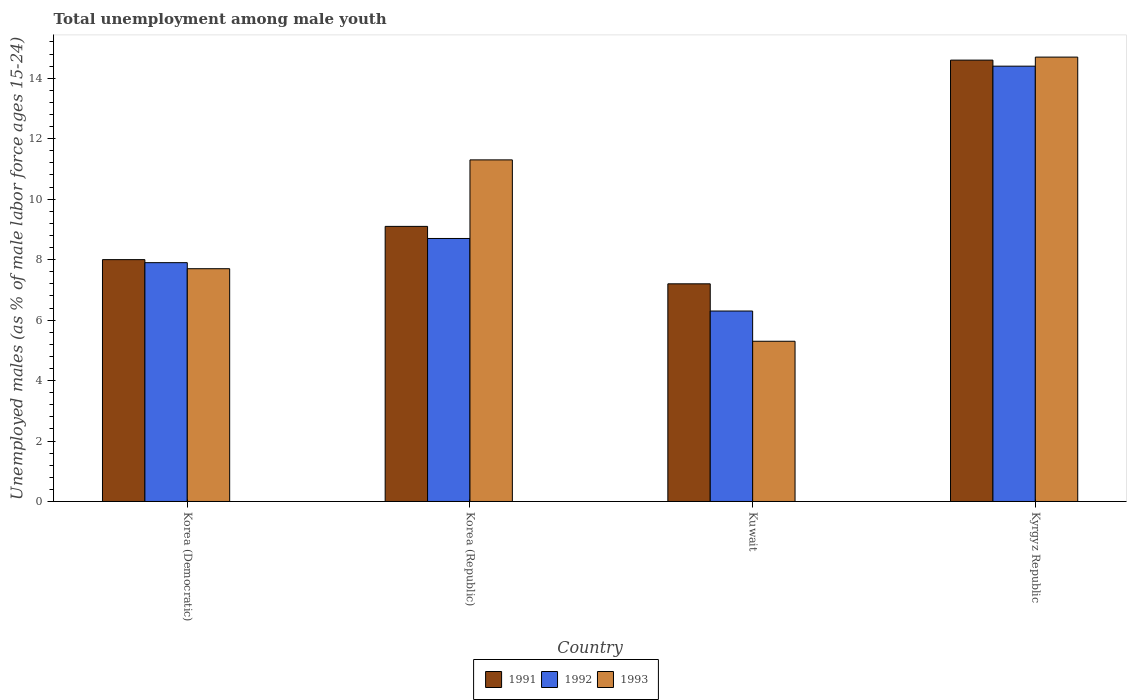Are the number of bars on each tick of the X-axis equal?
Keep it short and to the point. Yes. How many bars are there on the 3rd tick from the right?
Your answer should be very brief. 3. What is the label of the 3rd group of bars from the left?
Provide a short and direct response. Kuwait. What is the percentage of unemployed males in in 1993 in Korea (Republic)?
Your answer should be compact. 11.3. Across all countries, what is the maximum percentage of unemployed males in in 1991?
Make the answer very short. 14.6. Across all countries, what is the minimum percentage of unemployed males in in 1991?
Keep it short and to the point. 7.2. In which country was the percentage of unemployed males in in 1992 maximum?
Give a very brief answer. Kyrgyz Republic. In which country was the percentage of unemployed males in in 1991 minimum?
Offer a terse response. Kuwait. What is the total percentage of unemployed males in in 1991 in the graph?
Ensure brevity in your answer.  38.9. What is the difference between the percentage of unemployed males in in 1991 in Kuwait and that in Kyrgyz Republic?
Ensure brevity in your answer.  -7.4. What is the difference between the percentage of unemployed males in in 1993 in Korea (Democratic) and the percentage of unemployed males in in 1991 in Korea (Republic)?
Make the answer very short. -1.4. What is the average percentage of unemployed males in in 1993 per country?
Your answer should be very brief. 9.75. What is the difference between the percentage of unemployed males in of/in 1991 and percentage of unemployed males in of/in 1993 in Korea (Democratic)?
Make the answer very short. 0.3. In how many countries, is the percentage of unemployed males in in 1991 greater than 4 %?
Ensure brevity in your answer.  4. What is the ratio of the percentage of unemployed males in in 1993 in Kuwait to that in Kyrgyz Republic?
Provide a short and direct response. 0.36. Is the percentage of unemployed males in in 1992 in Korea (Democratic) less than that in Kyrgyz Republic?
Provide a short and direct response. Yes. What is the difference between the highest and the second highest percentage of unemployed males in in 1992?
Keep it short and to the point. -5.7. What is the difference between the highest and the lowest percentage of unemployed males in in 1993?
Give a very brief answer. 9.4. Is the sum of the percentage of unemployed males in in 1991 in Korea (Democratic) and Kuwait greater than the maximum percentage of unemployed males in in 1993 across all countries?
Provide a short and direct response. Yes. What does the 3rd bar from the left in Korea (Republic) represents?
Ensure brevity in your answer.  1993. Is it the case that in every country, the sum of the percentage of unemployed males in in 1991 and percentage of unemployed males in in 1993 is greater than the percentage of unemployed males in in 1992?
Offer a very short reply. Yes. How many countries are there in the graph?
Provide a succinct answer. 4. Are the values on the major ticks of Y-axis written in scientific E-notation?
Give a very brief answer. No. Does the graph contain grids?
Offer a very short reply. No. Where does the legend appear in the graph?
Offer a terse response. Bottom center. What is the title of the graph?
Provide a succinct answer. Total unemployment among male youth. What is the label or title of the X-axis?
Offer a terse response. Country. What is the label or title of the Y-axis?
Give a very brief answer. Unemployed males (as % of male labor force ages 15-24). What is the Unemployed males (as % of male labor force ages 15-24) of 1991 in Korea (Democratic)?
Ensure brevity in your answer.  8. What is the Unemployed males (as % of male labor force ages 15-24) of 1992 in Korea (Democratic)?
Offer a very short reply. 7.9. What is the Unemployed males (as % of male labor force ages 15-24) in 1993 in Korea (Democratic)?
Make the answer very short. 7.7. What is the Unemployed males (as % of male labor force ages 15-24) in 1991 in Korea (Republic)?
Provide a short and direct response. 9.1. What is the Unemployed males (as % of male labor force ages 15-24) of 1992 in Korea (Republic)?
Offer a very short reply. 8.7. What is the Unemployed males (as % of male labor force ages 15-24) of 1993 in Korea (Republic)?
Offer a terse response. 11.3. What is the Unemployed males (as % of male labor force ages 15-24) in 1991 in Kuwait?
Ensure brevity in your answer.  7.2. What is the Unemployed males (as % of male labor force ages 15-24) of 1992 in Kuwait?
Keep it short and to the point. 6.3. What is the Unemployed males (as % of male labor force ages 15-24) in 1993 in Kuwait?
Ensure brevity in your answer.  5.3. What is the Unemployed males (as % of male labor force ages 15-24) in 1991 in Kyrgyz Republic?
Offer a very short reply. 14.6. What is the Unemployed males (as % of male labor force ages 15-24) of 1992 in Kyrgyz Republic?
Your answer should be compact. 14.4. What is the Unemployed males (as % of male labor force ages 15-24) of 1993 in Kyrgyz Republic?
Your response must be concise. 14.7. Across all countries, what is the maximum Unemployed males (as % of male labor force ages 15-24) of 1991?
Your response must be concise. 14.6. Across all countries, what is the maximum Unemployed males (as % of male labor force ages 15-24) of 1992?
Provide a succinct answer. 14.4. Across all countries, what is the maximum Unemployed males (as % of male labor force ages 15-24) in 1993?
Give a very brief answer. 14.7. Across all countries, what is the minimum Unemployed males (as % of male labor force ages 15-24) of 1991?
Provide a short and direct response. 7.2. Across all countries, what is the minimum Unemployed males (as % of male labor force ages 15-24) of 1992?
Provide a short and direct response. 6.3. Across all countries, what is the minimum Unemployed males (as % of male labor force ages 15-24) in 1993?
Keep it short and to the point. 5.3. What is the total Unemployed males (as % of male labor force ages 15-24) of 1991 in the graph?
Provide a short and direct response. 38.9. What is the total Unemployed males (as % of male labor force ages 15-24) of 1992 in the graph?
Give a very brief answer. 37.3. What is the total Unemployed males (as % of male labor force ages 15-24) in 1993 in the graph?
Ensure brevity in your answer.  39. What is the difference between the Unemployed males (as % of male labor force ages 15-24) of 1992 in Korea (Democratic) and that in Korea (Republic)?
Keep it short and to the point. -0.8. What is the difference between the Unemployed males (as % of male labor force ages 15-24) of 1993 in Korea (Democratic) and that in Korea (Republic)?
Give a very brief answer. -3.6. What is the difference between the Unemployed males (as % of male labor force ages 15-24) in 1991 in Korea (Democratic) and that in Kuwait?
Your answer should be compact. 0.8. What is the difference between the Unemployed males (as % of male labor force ages 15-24) of 1992 in Korea (Democratic) and that in Kuwait?
Offer a very short reply. 1.6. What is the difference between the Unemployed males (as % of male labor force ages 15-24) of 1993 in Korea (Democratic) and that in Kuwait?
Offer a terse response. 2.4. What is the difference between the Unemployed males (as % of male labor force ages 15-24) in 1993 in Korea (Democratic) and that in Kyrgyz Republic?
Provide a succinct answer. -7. What is the difference between the Unemployed males (as % of male labor force ages 15-24) of 1991 in Korea (Republic) and that in Kuwait?
Keep it short and to the point. 1.9. What is the difference between the Unemployed males (as % of male labor force ages 15-24) of 1991 in Korea (Republic) and that in Kyrgyz Republic?
Provide a short and direct response. -5.5. What is the difference between the Unemployed males (as % of male labor force ages 15-24) in 1992 in Korea (Republic) and that in Kyrgyz Republic?
Your response must be concise. -5.7. What is the difference between the Unemployed males (as % of male labor force ages 15-24) of 1993 in Korea (Republic) and that in Kyrgyz Republic?
Make the answer very short. -3.4. What is the difference between the Unemployed males (as % of male labor force ages 15-24) in 1992 in Kuwait and that in Kyrgyz Republic?
Keep it short and to the point. -8.1. What is the difference between the Unemployed males (as % of male labor force ages 15-24) in 1993 in Kuwait and that in Kyrgyz Republic?
Your answer should be very brief. -9.4. What is the difference between the Unemployed males (as % of male labor force ages 15-24) in 1991 in Korea (Democratic) and the Unemployed males (as % of male labor force ages 15-24) in 1992 in Korea (Republic)?
Ensure brevity in your answer.  -0.7. What is the difference between the Unemployed males (as % of male labor force ages 15-24) in 1992 in Korea (Democratic) and the Unemployed males (as % of male labor force ages 15-24) in 1993 in Korea (Republic)?
Offer a terse response. -3.4. What is the difference between the Unemployed males (as % of male labor force ages 15-24) in 1991 in Korea (Democratic) and the Unemployed males (as % of male labor force ages 15-24) in 1993 in Kuwait?
Provide a succinct answer. 2.7. What is the difference between the Unemployed males (as % of male labor force ages 15-24) of 1992 in Korea (Democratic) and the Unemployed males (as % of male labor force ages 15-24) of 1993 in Kuwait?
Keep it short and to the point. 2.6. What is the difference between the Unemployed males (as % of male labor force ages 15-24) of 1991 in Korea (Democratic) and the Unemployed males (as % of male labor force ages 15-24) of 1993 in Kyrgyz Republic?
Ensure brevity in your answer.  -6.7. What is the difference between the Unemployed males (as % of male labor force ages 15-24) in 1992 in Korea (Democratic) and the Unemployed males (as % of male labor force ages 15-24) in 1993 in Kyrgyz Republic?
Give a very brief answer. -6.8. What is the difference between the Unemployed males (as % of male labor force ages 15-24) in 1991 in Korea (Republic) and the Unemployed males (as % of male labor force ages 15-24) in 1993 in Kuwait?
Offer a very short reply. 3.8. What is the difference between the Unemployed males (as % of male labor force ages 15-24) in 1992 in Korea (Republic) and the Unemployed males (as % of male labor force ages 15-24) in 1993 in Kyrgyz Republic?
Your response must be concise. -6. What is the difference between the Unemployed males (as % of male labor force ages 15-24) of 1992 in Kuwait and the Unemployed males (as % of male labor force ages 15-24) of 1993 in Kyrgyz Republic?
Offer a very short reply. -8.4. What is the average Unemployed males (as % of male labor force ages 15-24) of 1991 per country?
Your response must be concise. 9.72. What is the average Unemployed males (as % of male labor force ages 15-24) of 1992 per country?
Provide a short and direct response. 9.32. What is the average Unemployed males (as % of male labor force ages 15-24) of 1993 per country?
Offer a very short reply. 9.75. What is the difference between the Unemployed males (as % of male labor force ages 15-24) in 1991 and Unemployed males (as % of male labor force ages 15-24) in 1993 in Korea (Democratic)?
Your response must be concise. 0.3. What is the difference between the Unemployed males (as % of male labor force ages 15-24) of 1991 and Unemployed males (as % of male labor force ages 15-24) of 1992 in Korea (Republic)?
Give a very brief answer. 0.4. What is the difference between the Unemployed males (as % of male labor force ages 15-24) in 1991 and Unemployed males (as % of male labor force ages 15-24) in 1993 in Korea (Republic)?
Your answer should be compact. -2.2. What is the difference between the Unemployed males (as % of male labor force ages 15-24) in 1992 and Unemployed males (as % of male labor force ages 15-24) in 1993 in Korea (Republic)?
Make the answer very short. -2.6. What is the difference between the Unemployed males (as % of male labor force ages 15-24) of 1991 and Unemployed males (as % of male labor force ages 15-24) of 1993 in Kuwait?
Provide a succinct answer. 1.9. What is the difference between the Unemployed males (as % of male labor force ages 15-24) in 1992 and Unemployed males (as % of male labor force ages 15-24) in 1993 in Kuwait?
Give a very brief answer. 1. What is the difference between the Unemployed males (as % of male labor force ages 15-24) of 1991 and Unemployed males (as % of male labor force ages 15-24) of 1992 in Kyrgyz Republic?
Your response must be concise. 0.2. What is the difference between the Unemployed males (as % of male labor force ages 15-24) of 1991 and Unemployed males (as % of male labor force ages 15-24) of 1993 in Kyrgyz Republic?
Give a very brief answer. -0.1. What is the difference between the Unemployed males (as % of male labor force ages 15-24) of 1992 and Unemployed males (as % of male labor force ages 15-24) of 1993 in Kyrgyz Republic?
Provide a succinct answer. -0.3. What is the ratio of the Unemployed males (as % of male labor force ages 15-24) in 1991 in Korea (Democratic) to that in Korea (Republic)?
Give a very brief answer. 0.88. What is the ratio of the Unemployed males (as % of male labor force ages 15-24) in 1992 in Korea (Democratic) to that in Korea (Republic)?
Keep it short and to the point. 0.91. What is the ratio of the Unemployed males (as % of male labor force ages 15-24) of 1993 in Korea (Democratic) to that in Korea (Republic)?
Give a very brief answer. 0.68. What is the ratio of the Unemployed males (as % of male labor force ages 15-24) of 1992 in Korea (Democratic) to that in Kuwait?
Give a very brief answer. 1.25. What is the ratio of the Unemployed males (as % of male labor force ages 15-24) in 1993 in Korea (Democratic) to that in Kuwait?
Offer a very short reply. 1.45. What is the ratio of the Unemployed males (as % of male labor force ages 15-24) of 1991 in Korea (Democratic) to that in Kyrgyz Republic?
Offer a terse response. 0.55. What is the ratio of the Unemployed males (as % of male labor force ages 15-24) of 1992 in Korea (Democratic) to that in Kyrgyz Republic?
Your answer should be compact. 0.55. What is the ratio of the Unemployed males (as % of male labor force ages 15-24) of 1993 in Korea (Democratic) to that in Kyrgyz Republic?
Keep it short and to the point. 0.52. What is the ratio of the Unemployed males (as % of male labor force ages 15-24) of 1991 in Korea (Republic) to that in Kuwait?
Ensure brevity in your answer.  1.26. What is the ratio of the Unemployed males (as % of male labor force ages 15-24) in 1992 in Korea (Republic) to that in Kuwait?
Give a very brief answer. 1.38. What is the ratio of the Unemployed males (as % of male labor force ages 15-24) in 1993 in Korea (Republic) to that in Kuwait?
Offer a very short reply. 2.13. What is the ratio of the Unemployed males (as % of male labor force ages 15-24) of 1991 in Korea (Republic) to that in Kyrgyz Republic?
Your answer should be compact. 0.62. What is the ratio of the Unemployed males (as % of male labor force ages 15-24) of 1992 in Korea (Republic) to that in Kyrgyz Republic?
Provide a succinct answer. 0.6. What is the ratio of the Unemployed males (as % of male labor force ages 15-24) of 1993 in Korea (Republic) to that in Kyrgyz Republic?
Your answer should be very brief. 0.77. What is the ratio of the Unemployed males (as % of male labor force ages 15-24) of 1991 in Kuwait to that in Kyrgyz Republic?
Your answer should be very brief. 0.49. What is the ratio of the Unemployed males (as % of male labor force ages 15-24) in 1992 in Kuwait to that in Kyrgyz Republic?
Your response must be concise. 0.44. What is the ratio of the Unemployed males (as % of male labor force ages 15-24) in 1993 in Kuwait to that in Kyrgyz Republic?
Offer a very short reply. 0.36. What is the difference between the highest and the second highest Unemployed males (as % of male labor force ages 15-24) in 1993?
Offer a very short reply. 3.4. What is the difference between the highest and the lowest Unemployed males (as % of male labor force ages 15-24) of 1991?
Your answer should be very brief. 7.4. What is the difference between the highest and the lowest Unemployed males (as % of male labor force ages 15-24) in 1993?
Offer a terse response. 9.4. 